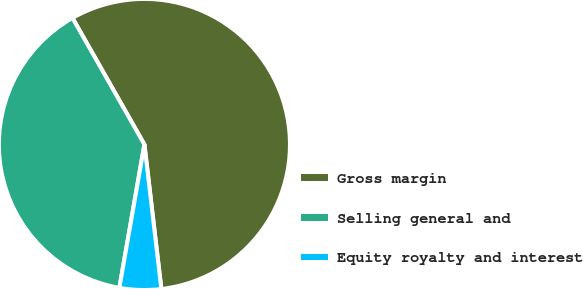<chart> <loc_0><loc_0><loc_500><loc_500><pie_chart><fcel>Gross margin<fcel>Selling general and<fcel>Equity royalty and interest<nl><fcel>56.37%<fcel>39.02%<fcel>4.61%<nl></chart> 